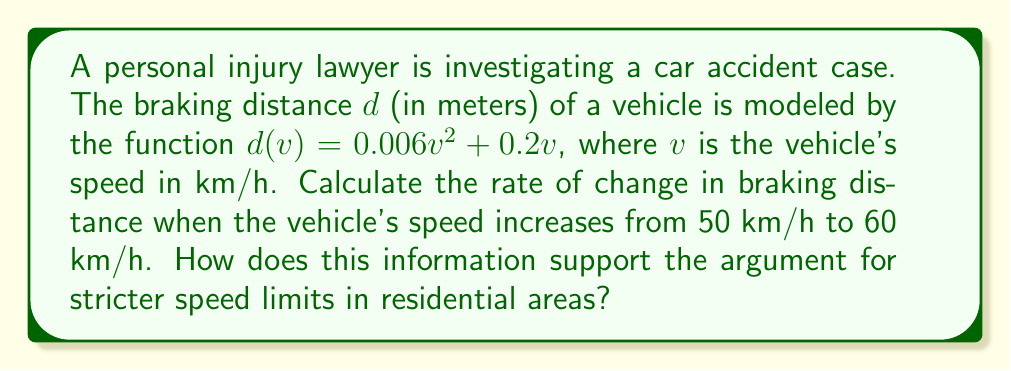Show me your answer to this math problem. 1) To find the rate of change in braking distance, we need to calculate the average rate of change of $d(v)$ between $v = 50$ and $v = 60$.

2) The average rate of change formula is:
   $$\frac{\Delta d}{\Delta v} = \frac{d(60) - d(50)}{60 - 50}$$

3) Let's calculate $d(50)$ and $d(60)$:
   
   $d(50) = 0.006(50)^2 + 0.2(50) = 15 + 10 = 25$ meters
   
   $d(60) = 0.006(60)^2 + 0.2(60) = 21.6 + 12 = 33.6$ meters

4) Now we can substitute these values into our rate of change formula:
   $$\frac{\Delta d}{\Delta v} = \frac{33.6 - 25}{60 - 50} = \frac{8.6}{10} = 0.86$$

5) This means that for each 1 km/h increase in speed between 50 and 60 km/h, the braking distance increases by 0.86 meters on average.

6) This significant increase in braking distance supports the argument for stricter speed limits in residential areas, as it demonstrates that even small increases in speed can substantially increase the distance required to stop, potentially putting pedestrians and other road users at greater risk.
Answer: 0.86 meters per km/h 